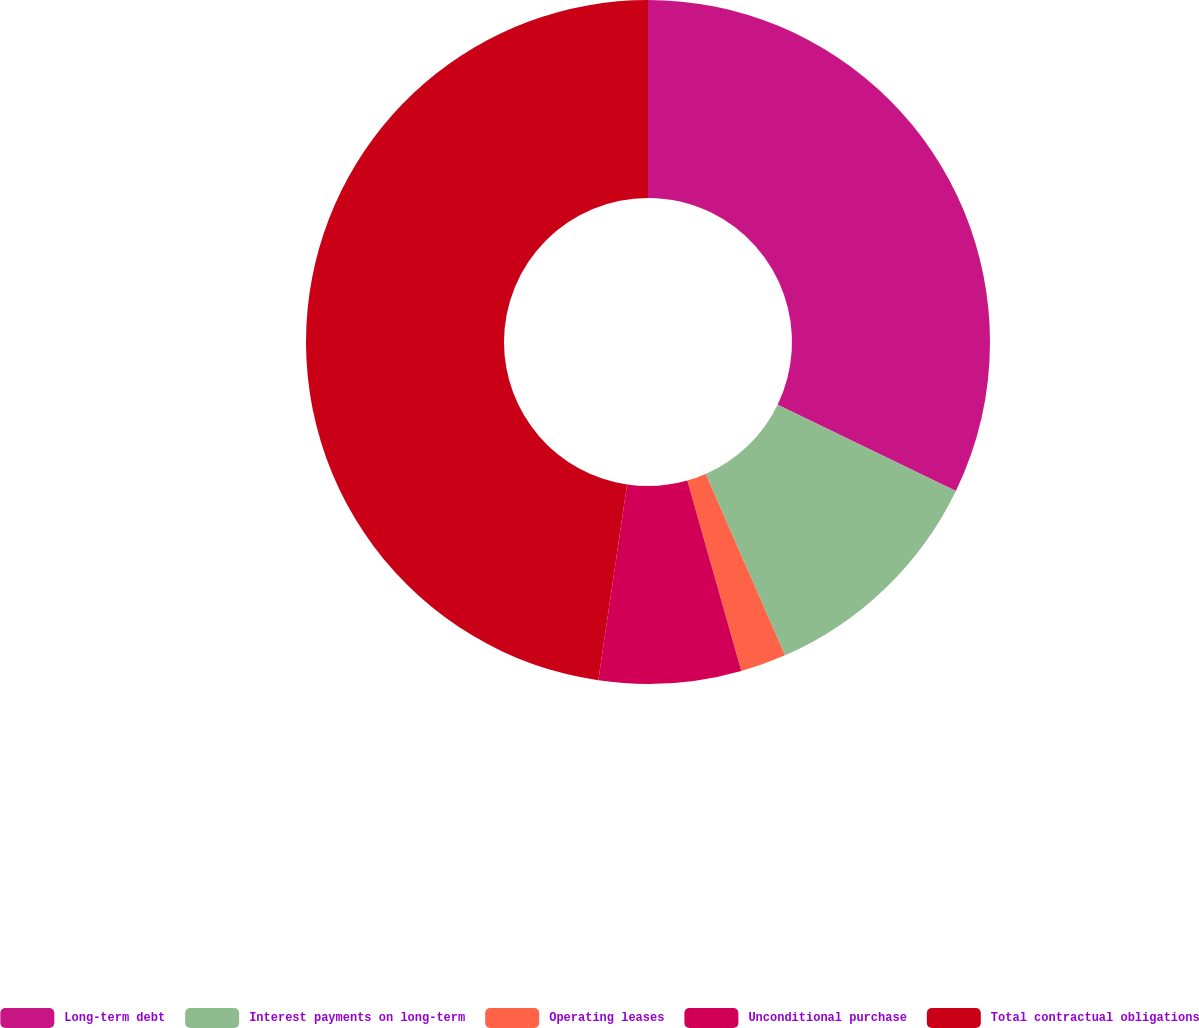Convert chart to OTSL. <chart><loc_0><loc_0><loc_500><loc_500><pie_chart><fcel>Long-term debt<fcel>Interest payments on long-term<fcel>Operating leases<fcel>Unconditional purchase<fcel>Total contractual obligations<nl><fcel>32.17%<fcel>11.27%<fcel>2.16%<fcel>6.72%<fcel>47.68%<nl></chart> 